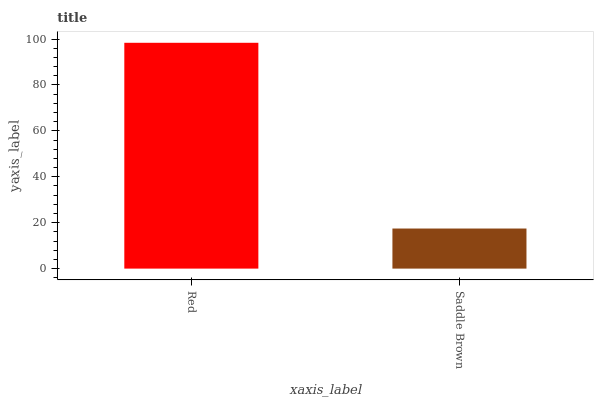Is Saddle Brown the minimum?
Answer yes or no. Yes. Is Red the maximum?
Answer yes or no. Yes. Is Saddle Brown the maximum?
Answer yes or no. No. Is Red greater than Saddle Brown?
Answer yes or no. Yes. Is Saddle Brown less than Red?
Answer yes or no. Yes. Is Saddle Brown greater than Red?
Answer yes or no. No. Is Red less than Saddle Brown?
Answer yes or no. No. Is Red the high median?
Answer yes or no. Yes. Is Saddle Brown the low median?
Answer yes or no. Yes. Is Saddle Brown the high median?
Answer yes or no. No. Is Red the low median?
Answer yes or no. No. 